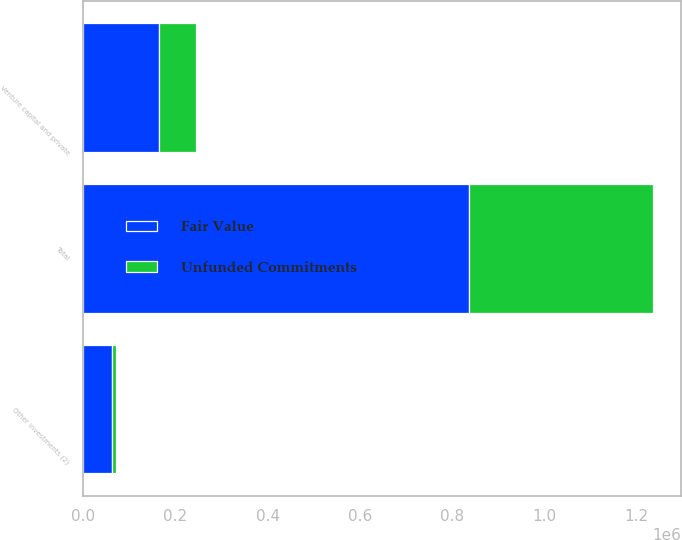Convert chart to OTSL. <chart><loc_0><loc_0><loc_500><loc_500><stacked_bar_chart><ecel><fcel>Venture capital and private<fcel>Other investments (2)<fcel>Total<nl><fcel>Fair Value<fcel>163674<fcel>61227<fcel>836725<nl><fcel>Unfunded Commitments<fcel>80010<fcel>8750<fcel>398525<nl></chart> 